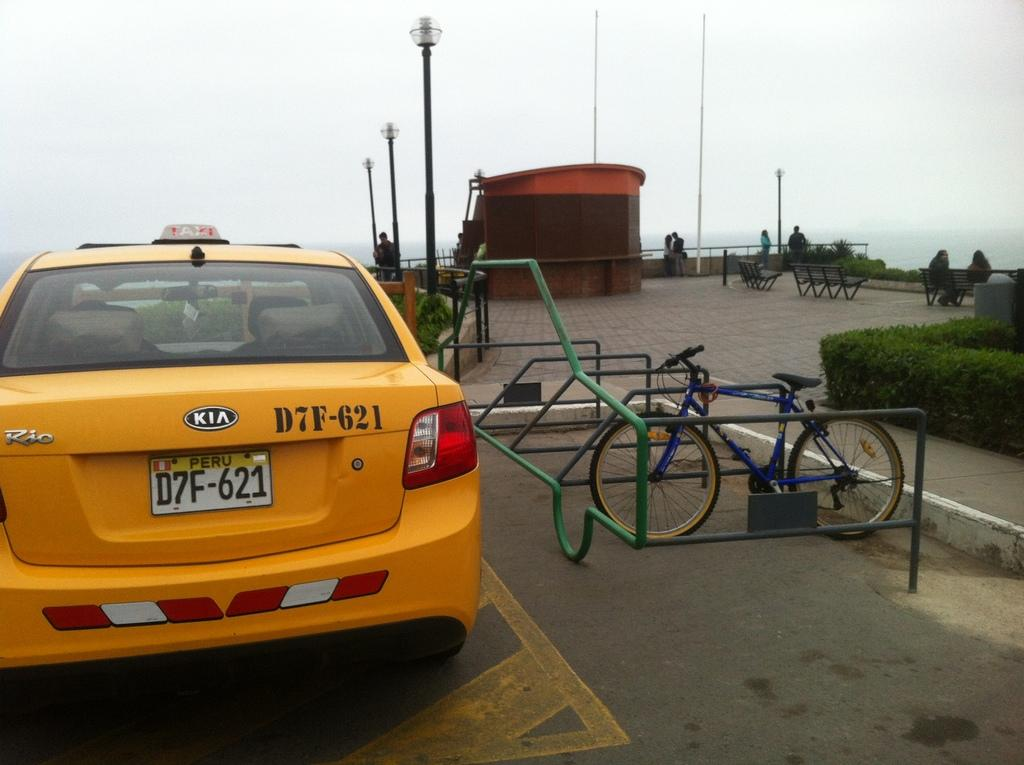<image>
Offer a succinct explanation of the picture presented. A yellow cab with the license plate D7F-621 is parked near a changed bicycle. 